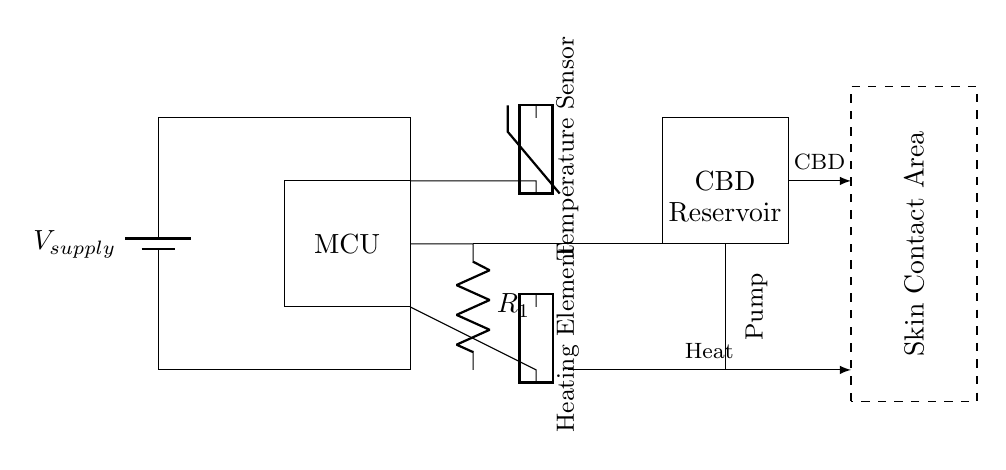What type of sensor is present in the circuit? The circuit includes a temperature sensor, as indicated by the labeled component connected to the thermistor, which measures temperature variations.
Answer: Temperature Sensor What component controls CBD delivery? The component responsible for CBD delivery is a pump, as shown connected to the CBD reservoir.
Answer: Pump How many main components are in this circuit? The circuit consists of five main components: a power supply, microcontroller, temperature sensor, heating element, and CBD reservoir with a pump.
Answer: Five What does the heating element do? The heating element is designed to generate heat, which is indicated by its connection and the labeled function in the circuit diagram.
Answer: Generate heat What connection connects the power supply to the microcontroller? The connection from the power supply to the microcontroller is a direct wired connection that supplies voltage, showing how power flows into the device.
Answer: Direct wired connection How is the CBD delivered to the skin contact area? CBD is delivered through the pump which pushes CBD from the reservoir to the skin contact area, visually represented by the directional arrow indicating flow towards the contact area.
Answer: Through the pump What is controlled by the microcontroller? The microcontroller controls both temperature measurement from the temperature sensor and the operation of the heating element and CBD pump, coordinating their functions based on patient needs.
Answer: Temperature and CBD delivery 